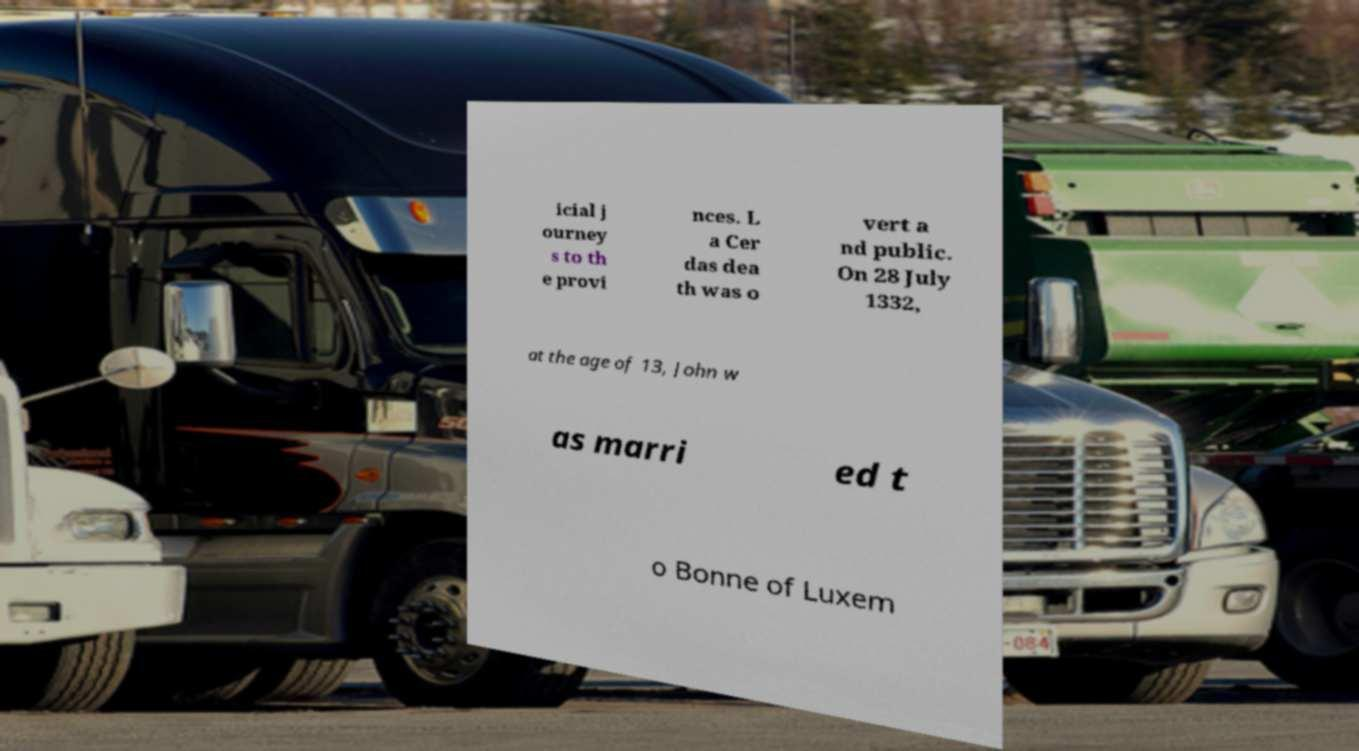For documentation purposes, I need the text within this image transcribed. Could you provide that? icial j ourney s to th e provi nces. L a Cer das dea th was o vert a nd public. On 28 July 1332, at the age of 13, John w as marri ed t o Bonne of Luxem 